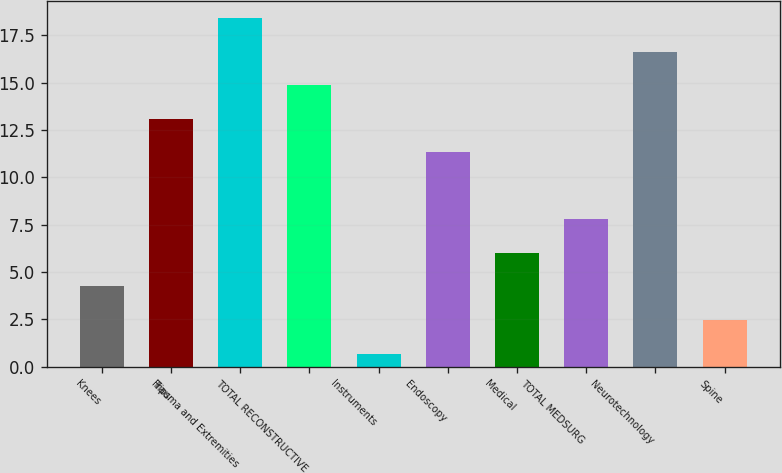Convert chart. <chart><loc_0><loc_0><loc_500><loc_500><bar_chart><fcel>Knees<fcel>Hips<fcel>Trauma and Extremities<fcel>TOTAL RECONSTRUCTIVE<fcel>Instruments<fcel>Endoscopy<fcel>Medical<fcel>TOTAL MEDSURG<fcel>Neurotechnology<fcel>Spine<nl><fcel>4.24<fcel>13.09<fcel>18.4<fcel>14.86<fcel>0.7<fcel>11.32<fcel>6.01<fcel>7.78<fcel>16.63<fcel>2.47<nl></chart> 